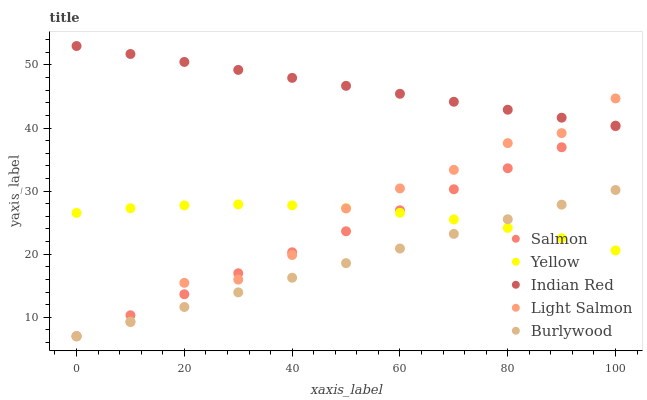Does Burlywood have the minimum area under the curve?
Answer yes or no. Yes. Does Indian Red have the maximum area under the curve?
Answer yes or no. Yes. Does Light Salmon have the minimum area under the curve?
Answer yes or no. No. Does Light Salmon have the maximum area under the curve?
Answer yes or no. No. Is Indian Red the smoothest?
Answer yes or no. Yes. Is Light Salmon the roughest?
Answer yes or no. Yes. Is Salmon the smoothest?
Answer yes or no. No. Is Salmon the roughest?
Answer yes or no. No. Does Burlywood have the lowest value?
Answer yes or no. Yes. Does Indian Red have the lowest value?
Answer yes or no. No. Does Indian Red have the highest value?
Answer yes or no. Yes. Does Light Salmon have the highest value?
Answer yes or no. No. Is Burlywood less than Indian Red?
Answer yes or no. Yes. Is Indian Red greater than Salmon?
Answer yes or no. Yes. Does Salmon intersect Light Salmon?
Answer yes or no. Yes. Is Salmon less than Light Salmon?
Answer yes or no. No. Is Salmon greater than Light Salmon?
Answer yes or no. No. Does Burlywood intersect Indian Red?
Answer yes or no. No. 